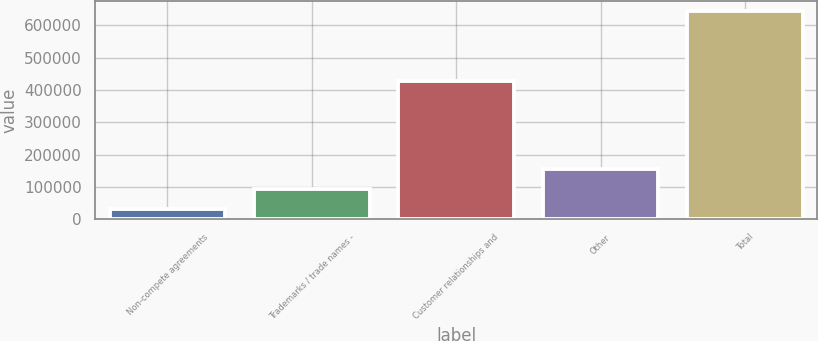Convert chart to OTSL. <chart><loc_0><loc_0><loc_500><loc_500><bar_chart><fcel>Non-compete agreements<fcel>Trademarks / trade names -<fcel>Customer relationships and<fcel>Other<fcel>Total<nl><fcel>33454<fcel>94482.2<fcel>428032<fcel>155510<fcel>643736<nl></chart> 